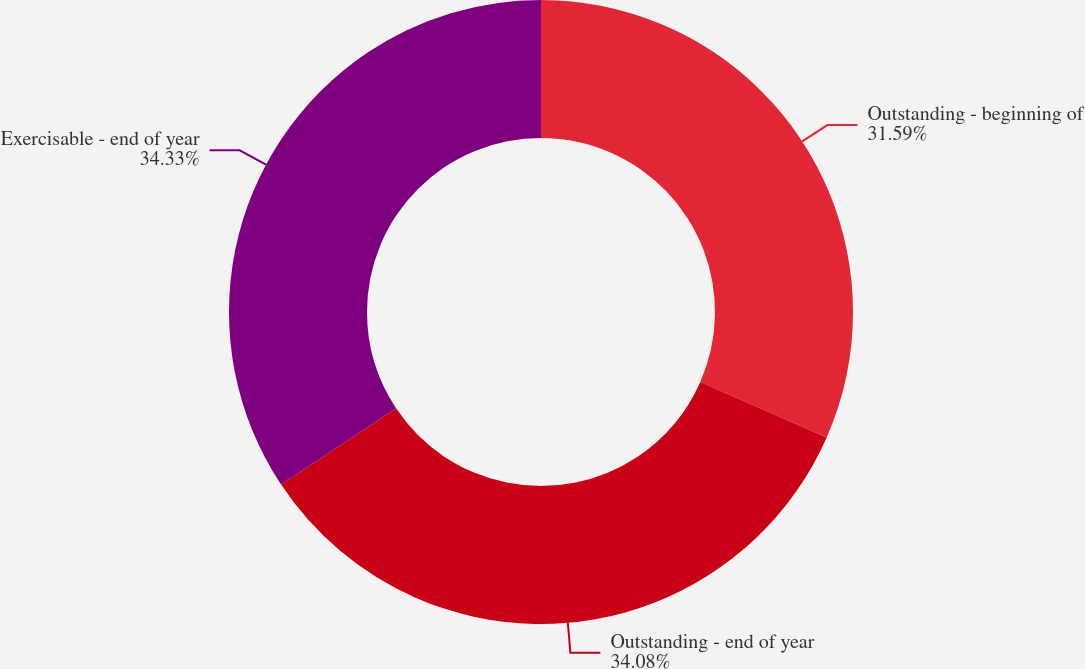Convert chart. <chart><loc_0><loc_0><loc_500><loc_500><pie_chart><fcel>Outstanding - beginning of<fcel>Outstanding - end of year<fcel>Exercisable - end of year<nl><fcel>31.59%<fcel>34.08%<fcel>34.33%<nl></chart> 